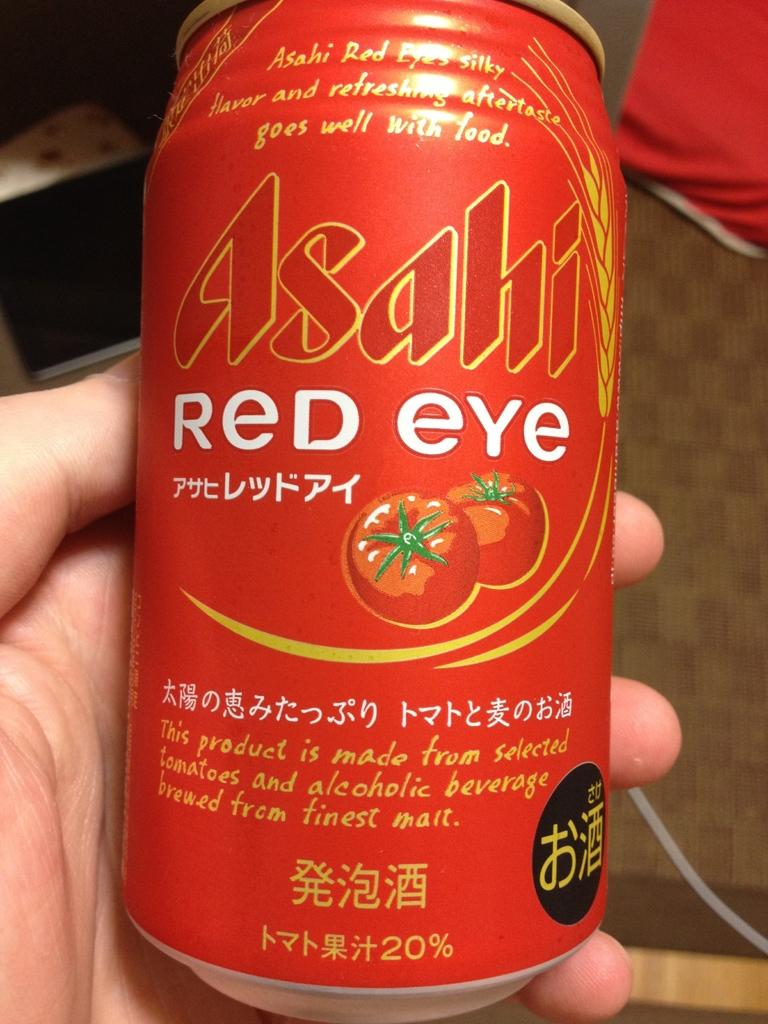Provide a one-sentence caption for the provided image. Asashi Red Eye Tomato type juice can that says it goes well with food and has a refreshing aftertaste. 